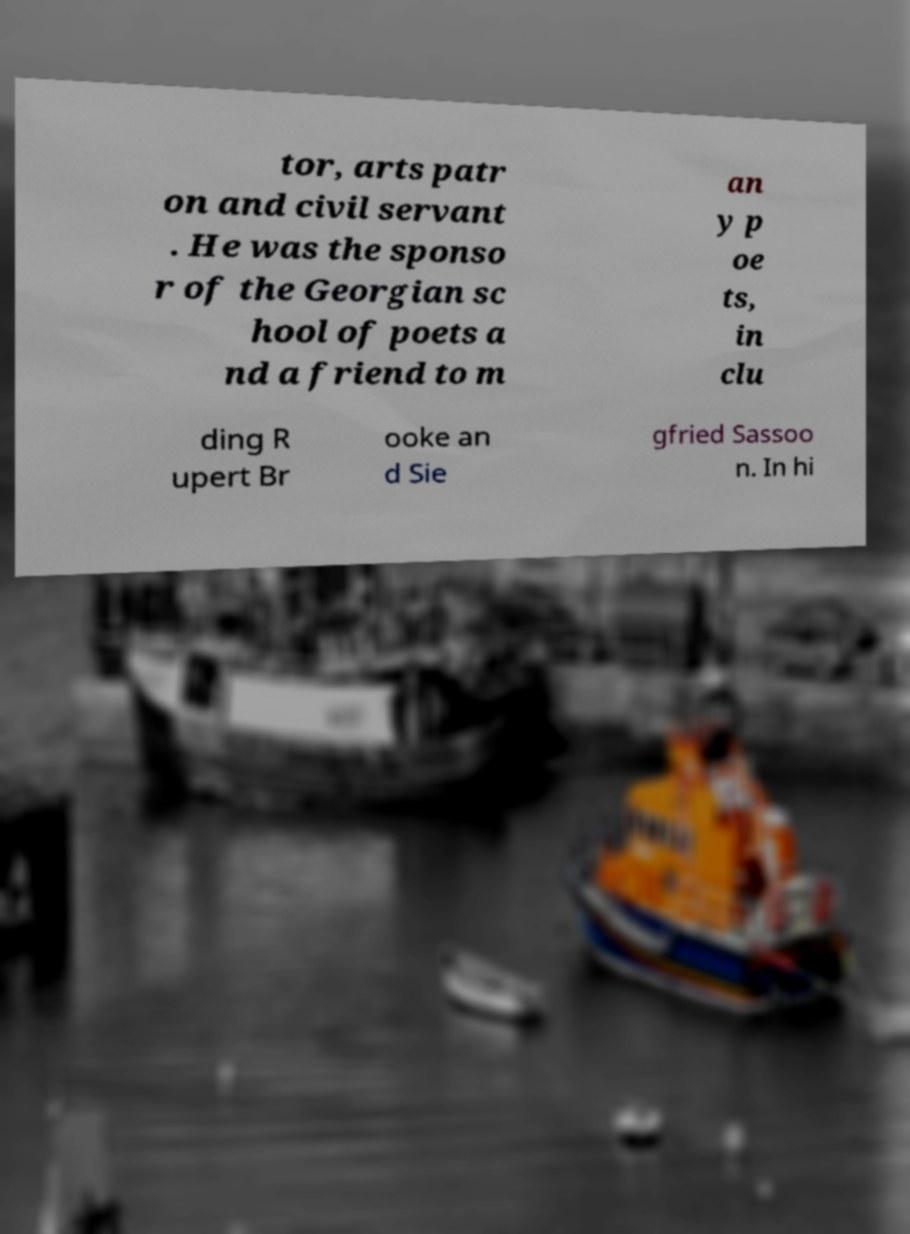I need the written content from this picture converted into text. Can you do that? tor, arts patr on and civil servant . He was the sponso r of the Georgian sc hool of poets a nd a friend to m an y p oe ts, in clu ding R upert Br ooke an d Sie gfried Sassoo n. In hi 